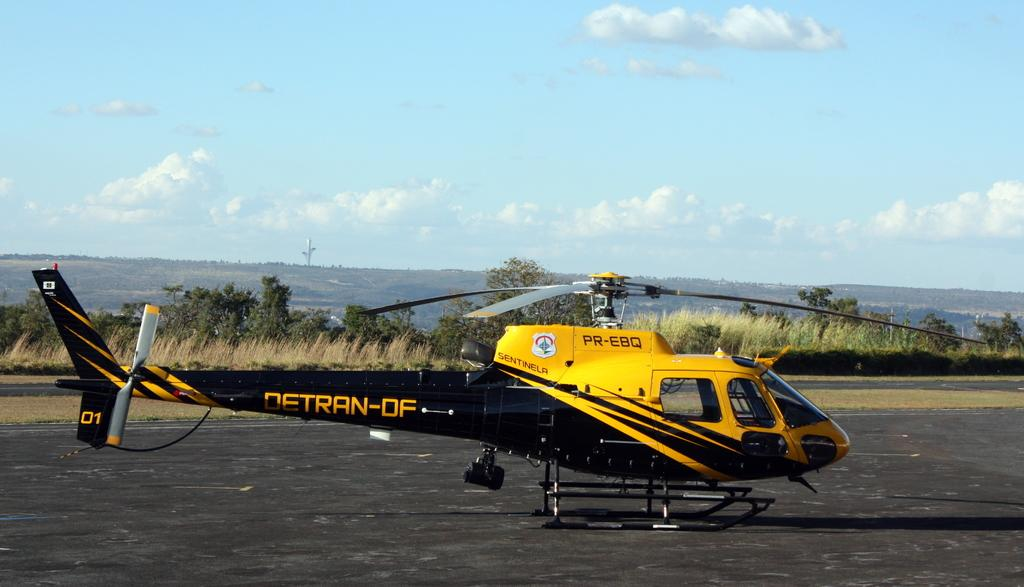<image>
Offer a succinct explanation of the picture presented. A sleek looking helicopter is labeled with the letters PR-EBQ. 